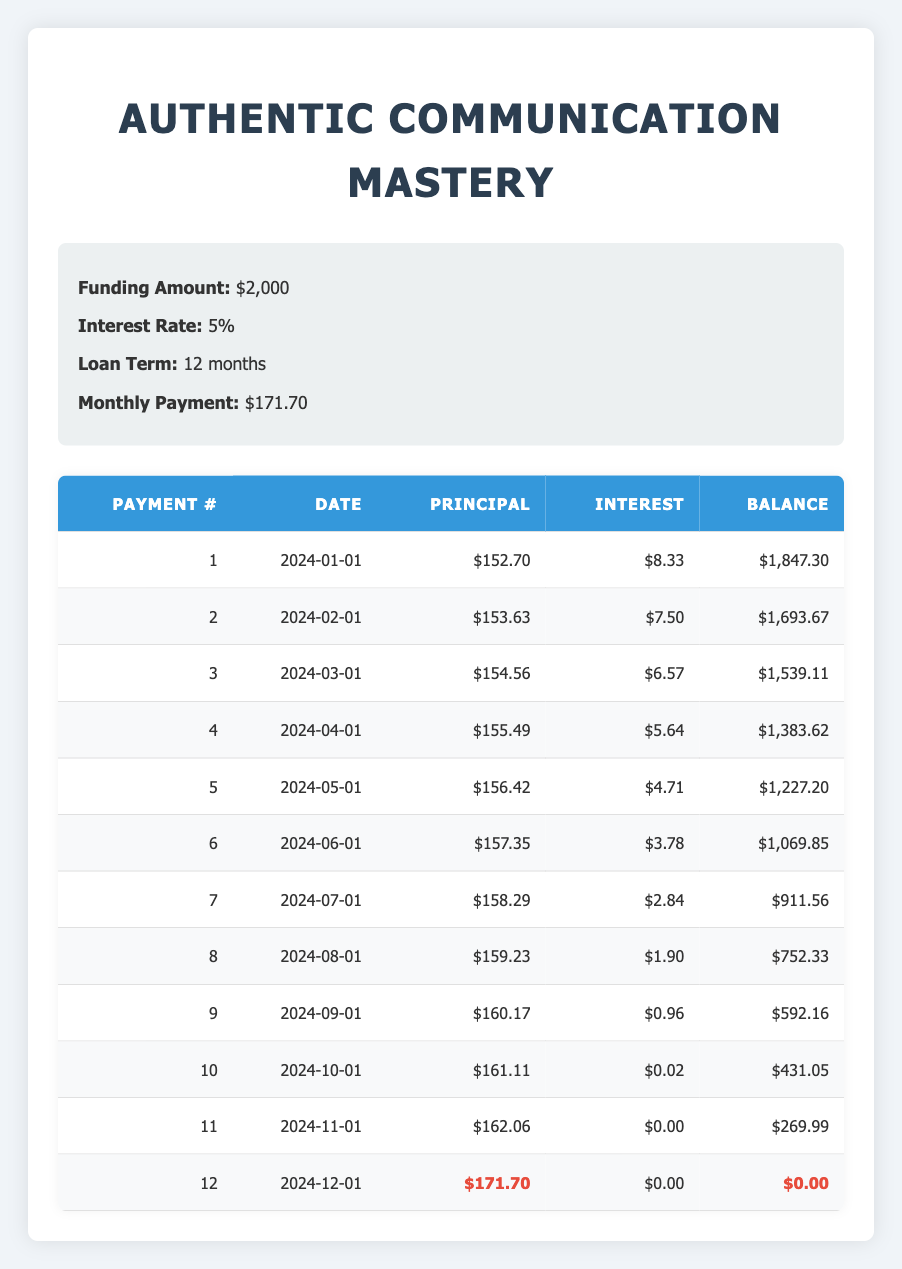What is the monthly payment for the course? The table specifies the monthly payment as $171.70 under the "Monthly Payment" section.
Answer: $171.70 What is the total amount paid at the end of the loan term? To find the total amount paid, multiply the monthly payment by the number of months. Thus, $171.70 * 12 = $2,060.40.
Answer: $2,060.40 Is the interest payment in the first month higher than in the second month? In the first month, the interest payment is $8.33, and in the second month, it's $7.50. Since $8.33 is greater than $7.50, the statement is true.
Answer: Yes What is the difference between the principal payment in the first month and the principal payment in the last month? The principal payment in the first month is $152.70, and in the last month, it is $171.70. The difference is $171.70 - $152.70 = $19.00.
Answer: $19.00 How much interest payment is made over the entire loan term? To find the total interest paid, we can sum all the monthly interest payments: $8.33 + $7.50 + $6.57 + $5.64 + $4.71 + $3.78 + $2.84 + $1.90 + $0.96 + $0.02 + $0.00 + $0.00 = $41.24.
Answer: $41.24 On what date is the final payment due? The last payment is noted in the 12th row under the "Date" column, which lists the date as 2024-12-01.
Answer: 2024-12-01 What is the remaining balance after the fifth payment? Referring to the table, after the fifth payment, the remaining balance is $1,227.20 as per the balance column corresponding to payment number 5.
Answer: $1,227.20 Do the principal payments increase or decrease monthly? Analyzing the principal payments from the table, they are all increasing each month (from $152.70 in the first month to $171.70 in the last month), indicating a consistent rise.
Answer: Increase What would be the total payments made excluding interest? The total principal payment over 12 months can be calculated by adding the principal amounts: ($152.70 + $153.63 + $154.56 + $155.49 + $156.42 + $157.35 + $158.29 + $159.23 + $160.17 + $161.11 + $162.06 + $171.70) = $1,880.99.
Answer: $1,880.99 